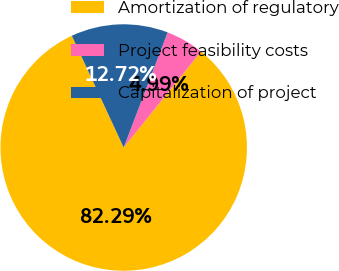Convert chart. <chart><loc_0><loc_0><loc_500><loc_500><pie_chart><fcel>Amortization of regulatory<fcel>Project feasibility costs<fcel>Capitalization of project<nl><fcel>82.29%<fcel>4.99%<fcel>12.72%<nl></chart> 